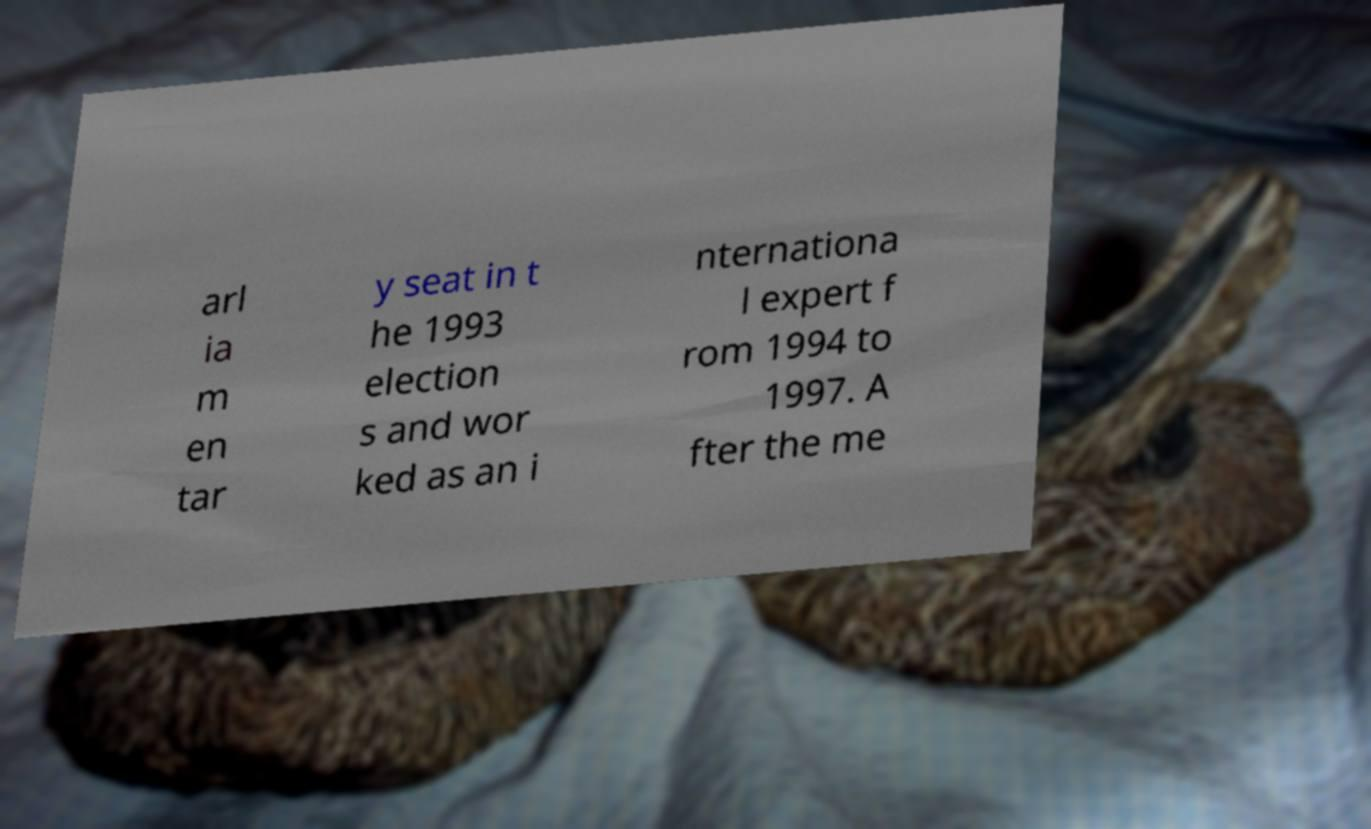For documentation purposes, I need the text within this image transcribed. Could you provide that? arl ia m en tar y seat in t he 1993 election s and wor ked as an i nternationa l expert f rom 1994 to 1997. A fter the me 